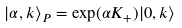<formula> <loc_0><loc_0><loc_500><loc_500>| \alpha , k \rangle _ { P } = \exp ( \alpha K _ { + } ) | 0 , k \rangle</formula> 